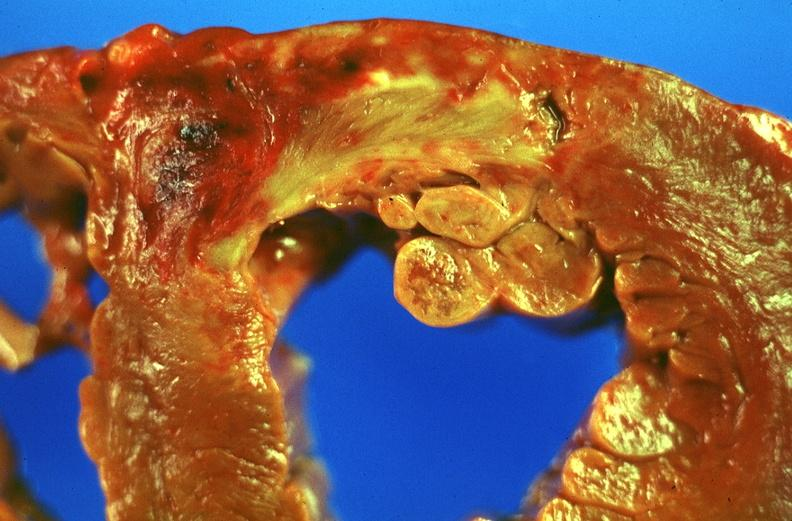s cardiovascular present?
Answer the question using a single word or phrase. Yes 